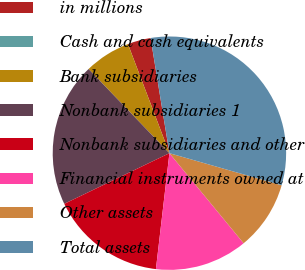<chart> <loc_0><loc_0><loc_500><loc_500><pie_chart><fcel>in millions<fcel>Cash and cash equivalents<fcel>Bank subsidiaries<fcel>Nonbank subsidiaries 1<fcel>Nonbank subsidiaries and other<fcel>Financial instruments owned at<fcel>Other assets<fcel>Total assets<nl><fcel>3.2%<fcel>0.0%<fcel>6.4%<fcel>19.96%<fcel>16.01%<fcel>12.81%<fcel>9.6%<fcel>32.01%<nl></chart> 